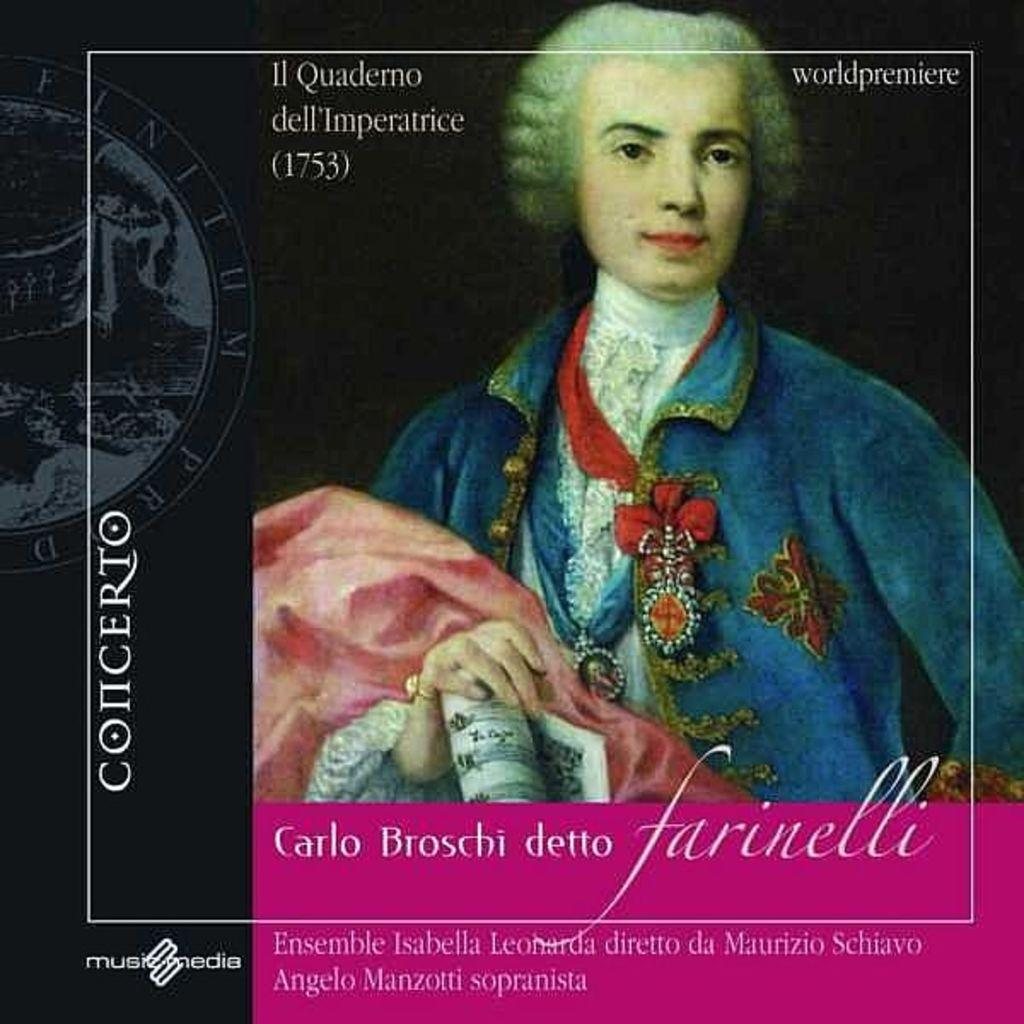What type of visual is the image? The image is a poster. Who or what is the main subject of the poster? There is a person in the center of the poster. What is the person holding in the poster? The person is holding a paper. Are there any words or phrases on the poster? Yes, there is text on the poster. Can you see any arches in the poster? There is no mention of an arch in the provided facts, so it cannot be determined if there is one present in the poster. How many roses are visible in the poster? There is no mention of roses in the provided facts, so it cannot be determined if there are any present in the poster. 